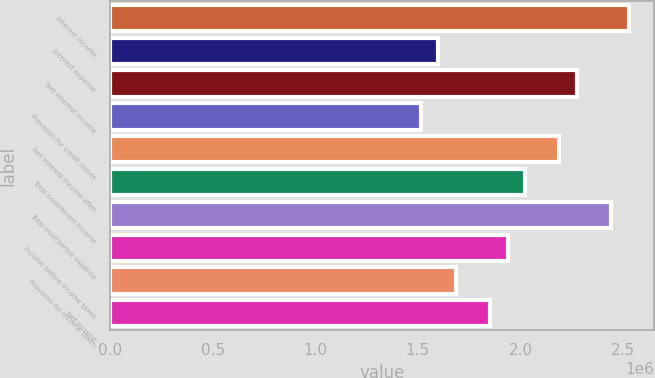Convert chart to OTSL. <chart><loc_0><loc_0><loc_500><loc_500><bar_chart><fcel>Interest income<fcel>Interest expense<fcel>Net interest income<fcel>Provision for credit losses<fcel>Net interest income after<fcel>Total noninterest income<fcel>Total noninterest expense<fcel>Income before income taxes<fcel>Provision for income taxes<fcel>Net income<nl><fcel>2.52697e+06<fcel>1.60042e+06<fcel>2.27427e+06<fcel>1.51618e+06<fcel>2.19004e+06<fcel>2.02158e+06<fcel>2.44274e+06<fcel>1.93735e+06<fcel>1.68465e+06<fcel>1.85311e+06<nl></chart> 